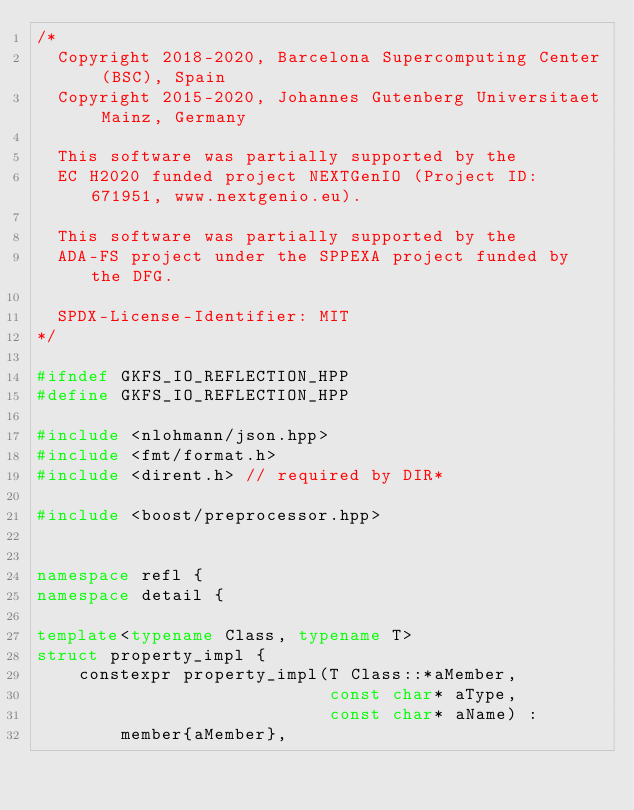<code> <loc_0><loc_0><loc_500><loc_500><_C++_>/*
  Copyright 2018-2020, Barcelona Supercomputing Center (BSC), Spain
  Copyright 2015-2020, Johannes Gutenberg Universitaet Mainz, Germany

  This software was partially supported by the
  EC H2020 funded project NEXTGenIO (Project ID: 671951, www.nextgenio.eu).

  This software was partially supported by the
  ADA-FS project under the SPPEXA project funded by the DFG.

  SPDX-License-Identifier: MIT
*/

#ifndef GKFS_IO_REFLECTION_HPP
#define GKFS_IO_REFLECTION_HPP

#include <nlohmann/json.hpp>
#include <fmt/format.h>
#include <dirent.h> // required by DIR*

#include <boost/preprocessor.hpp>


namespace refl {
namespace detail {

template<typename Class, typename T>
struct property_impl {
    constexpr property_impl(T Class::*aMember, 
                            const char* aType, 
                            const char* aName) : 
        member{aMember}, </code> 